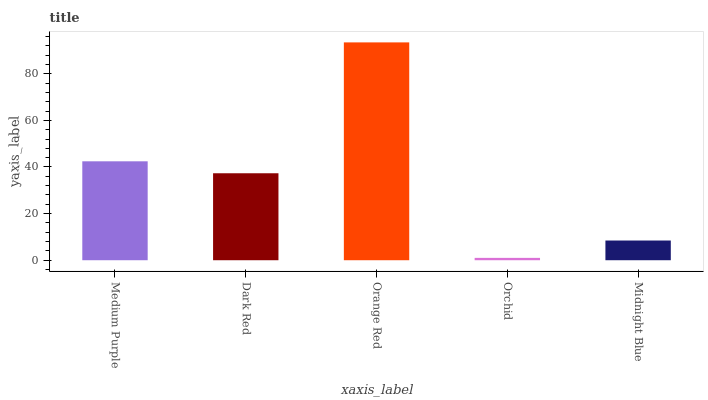Is Orchid the minimum?
Answer yes or no. Yes. Is Orange Red the maximum?
Answer yes or no. Yes. Is Dark Red the minimum?
Answer yes or no. No. Is Dark Red the maximum?
Answer yes or no. No. Is Medium Purple greater than Dark Red?
Answer yes or no. Yes. Is Dark Red less than Medium Purple?
Answer yes or no. Yes. Is Dark Red greater than Medium Purple?
Answer yes or no. No. Is Medium Purple less than Dark Red?
Answer yes or no. No. Is Dark Red the high median?
Answer yes or no. Yes. Is Dark Red the low median?
Answer yes or no. Yes. Is Midnight Blue the high median?
Answer yes or no. No. Is Orange Red the low median?
Answer yes or no. No. 